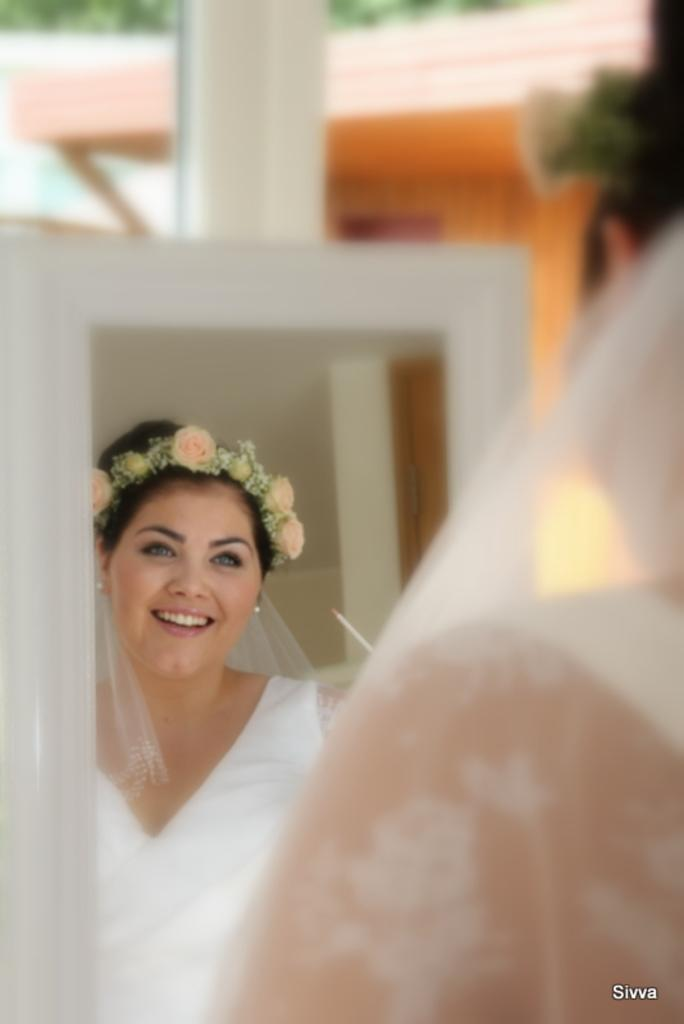Who is present in the image? There is a woman in the image. What object is in front of the woman? There is a mirror in front of the woman. What can be seen in the mirror's reflection? The reflection of the woman in the mirror shows her wearing a tiara. How would you describe the background of the image? The background of the image is blurry. How does the woman feel about the drain in the image? There is no drain present in the image, so it is not possible to determine how the woman feels about it. 